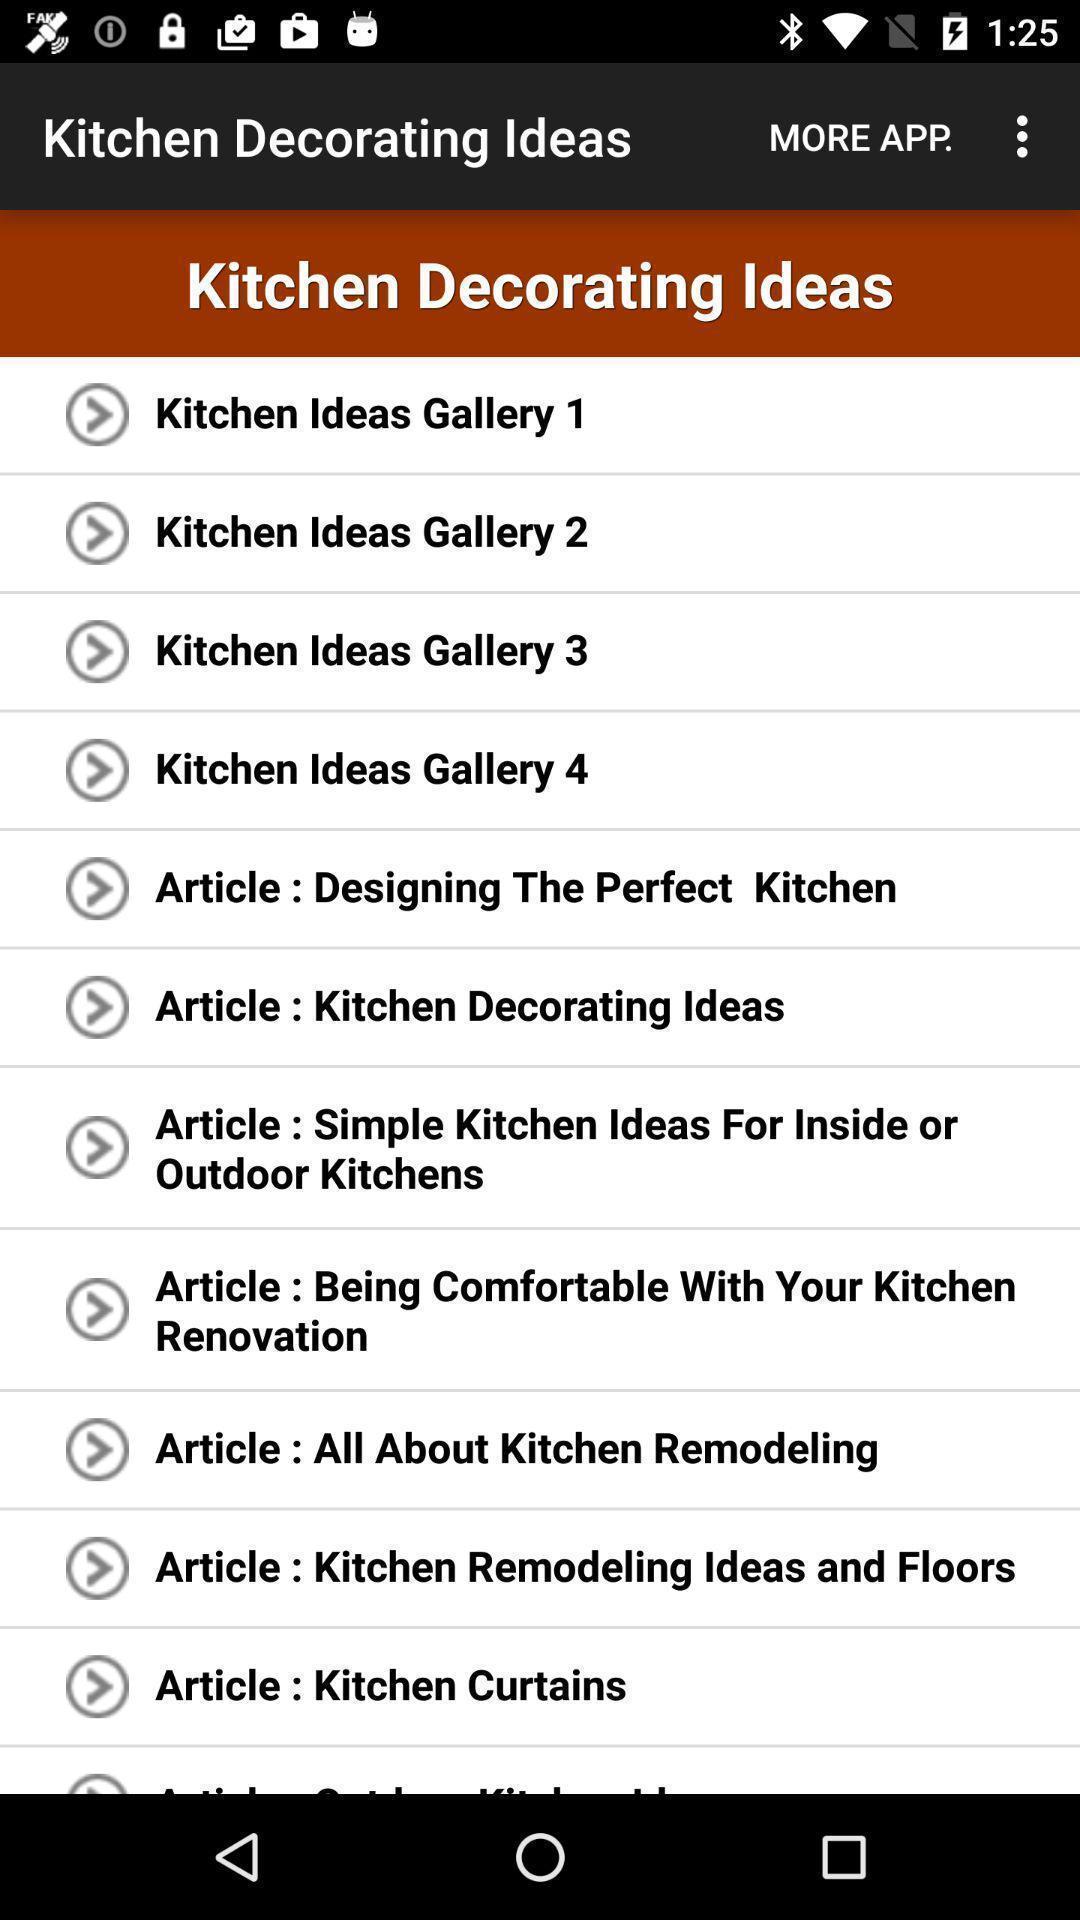Provide a description of this screenshot. Screen page displaying list of various options. 